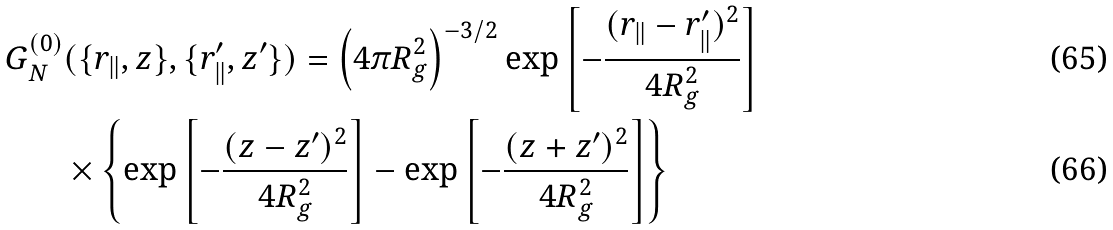Convert formula to latex. <formula><loc_0><loc_0><loc_500><loc_500>G _ { N } ^ { ( 0 ) } & ( \{ { r _ { \| } } , z \} , \{ { r _ { \| } ^ { \prime } } , z ^ { \prime } \} ) = \left ( 4 \pi R _ { g } ^ { 2 } \right ) ^ { - 3 / 2 } \exp \left [ - \frac { ( { r _ { \| } } - { r _ { \| } ^ { \prime } } ) ^ { 2 } } { 4 R _ { g } ^ { 2 } } \right ] \\ & \times \left \{ \exp \left [ - \frac { ( z - z ^ { \prime } ) ^ { 2 } } { 4 R _ { g } ^ { 2 } } \right ] - \exp \left [ - \frac { ( z + z ^ { \prime } ) ^ { 2 } } { 4 R _ { g } ^ { 2 } } \right ] \right \}</formula> 